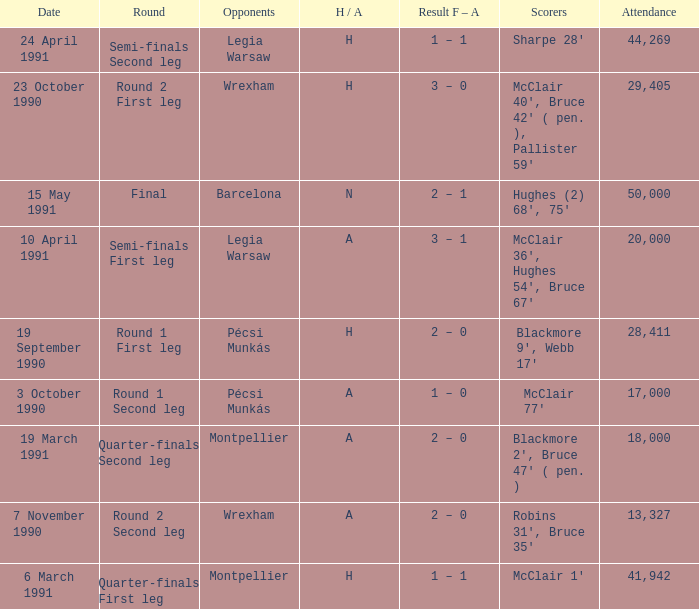What is the opponent name when the H/A is h with more than 28,411 in attendance and Sharpe 28' is the scorer? Legia Warsaw. 